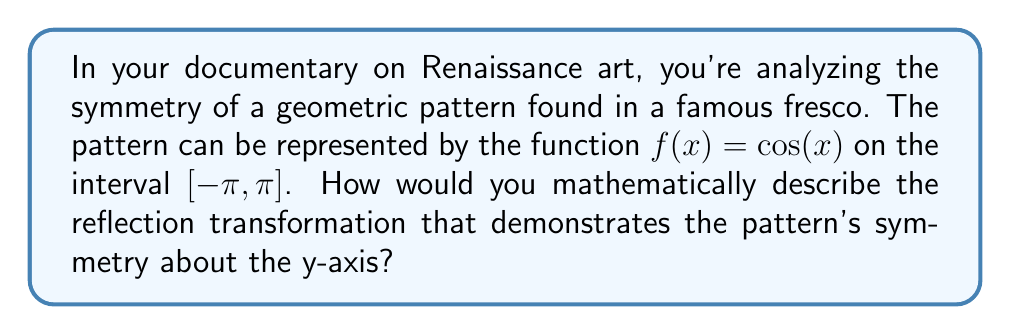Can you solve this math problem? To demonstrate the symmetry of the pattern about the y-axis, we need to find a reflection transformation that leaves the function unchanged. Let's approach this step-by-step:

1. The general form of a reflection about the y-axis is $g(x) = f(-x)$.

2. Apply this transformation to our function:
   $g(x) = f(-x) = \cos(-x)$

3. Now, we need to recall a fundamental property of cosine:
   $\cos(-x) = \cos(x)$

4. Therefore:
   $g(x) = \cos(-x) = \cos(x) = f(x)$

5. This equality $g(x) = f(x)$ shows that the function remains unchanged after reflection about the y-axis, proving it is symmetric about this axis.

6. Mathematically, we can express this symmetry as:
   $f(x) = f(-x)$ for all $x$ in the domain $[-\pi, \pi]$

This reflection transformation demonstrates that the geometric pattern in the fresco has even symmetry, a characteristic often found in Renaissance art to create balance and harmony in compositions.
Answer: $f(x) = f(-x)$, where $f(x) = \cos(x)$ 